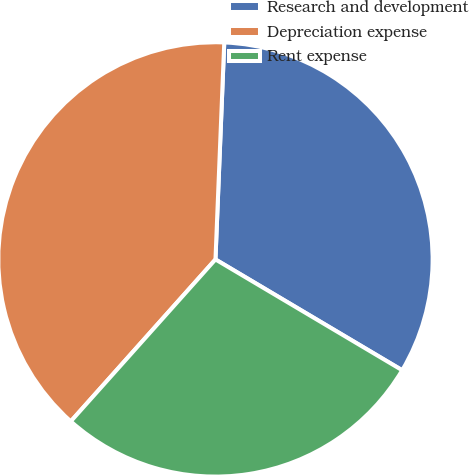Convert chart to OTSL. <chart><loc_0><loc_0><loc_500><loc_500><pie_chart><fcel>Research and development<fcel>Depreciation expense<fcel>Rent expense<nl><fcel>32.88%<fcel>39.04%<fcel>28.08%<nl></chart> 